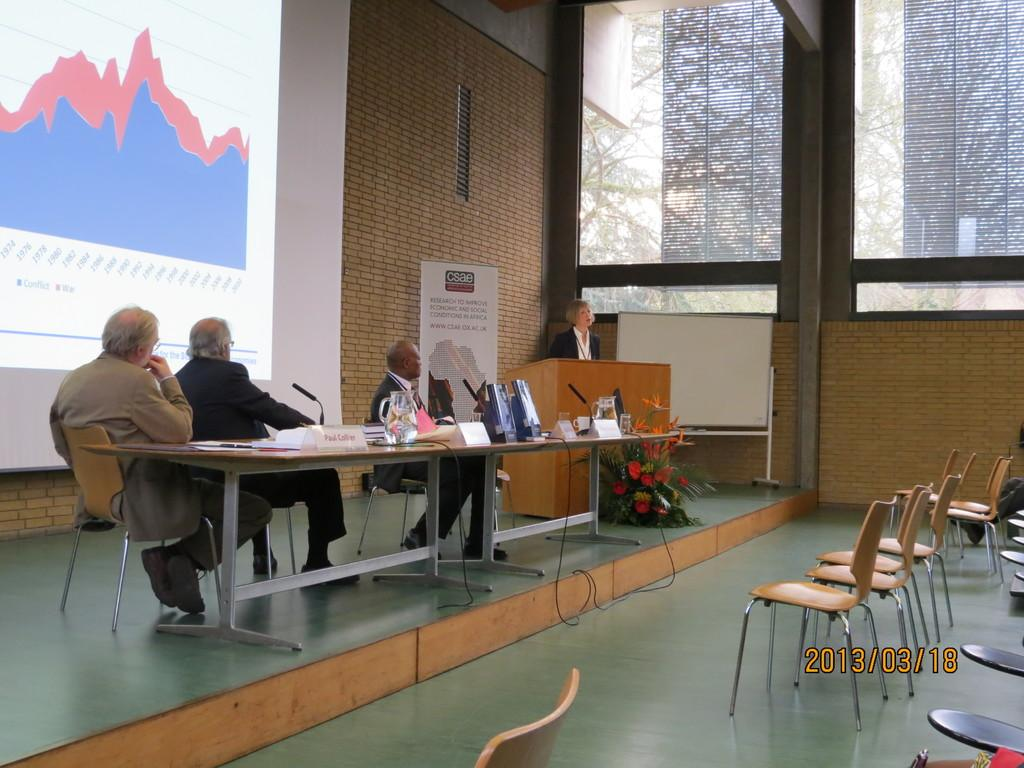What type of structure is visible in the image? There is a brick wall in the image. What can be seen in the brick wall? There is a window in the image. What is present on the window? There is a screen in the image. What are the people in the image doing? There are people sitting on chairs in the image. What is on the table in the image? There are mugs, laptops, and posters on the table. What type of air can be seen coming out of the yoke in the image? There is no yoke present in the image, and therefore no air coming out of it. 